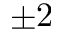Convert formula to latex. <formula><loc_0><loc_0><loc_500><loc_500>\pm 2</formula> 